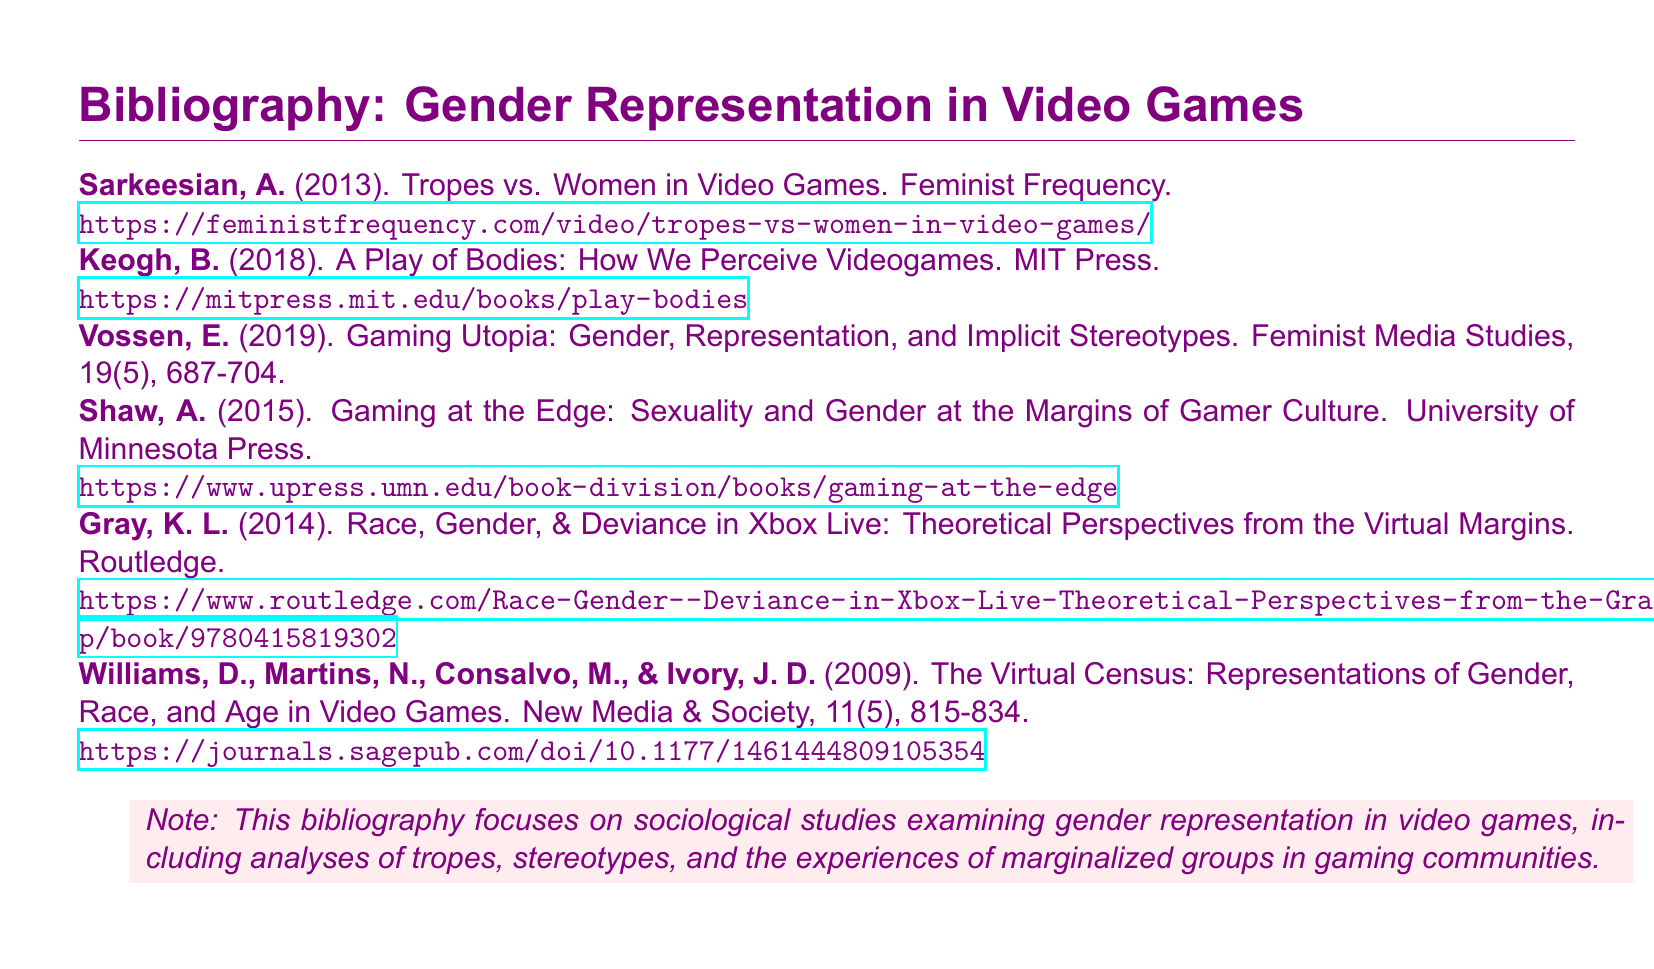What is the title of the first entry? The title of the first entry is the name of the work listed by Sarkeesian, which discusses tropes related to women in video games.
Answer: Tropes vs. Women in Video Games Who is the author of "Gaming at the Edge"? The author of "Gaming at the Edge" is A. Shaw, one of the contributors to the study of gender and sexuality in gaming culture.
Answer: A. Shaw In what year was "The Virtual Census" published? "The Virtual Census" was published in 2009, as recorded in the citation in the bibliography.
Answer: 2009 What type of studies does the note mention this bibliography focuses on? The note explicitly mentions that the bibliography focuses on sociological studies regarding the representation of gender in video games.
Answer: Sociological studies Which publication contains the work "A Play of Bodies"? "A Play of Bodies" is published by MIT Press, indicating its source for readers looking for the book.
Answer: MIT Press How many authors are listed for the entry "The Virtual Census"? The entry for "The Virtual Census" lists four authors in total, whose contributions provide a comprehensive view of the study.
Answer: Four What is the volume number of the journal that published "Gaming Utopia"? The journal that published "Gaming Utopia" is identified as having volume 19.
Answer: 19 What is the color used for the background of the note? The background of the note is highlighted in a specific color described in the document as "gamerpink."
Answer: gamerpink 